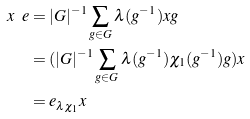<formula> <loc_0><loc_0><loc_500><loc_500>x \ e & = | G | ^ { - 1 } \sum _ { g \in G } \lambda ( g ^ { - 1 } ) x g \\ & = ( | G | ^ { - 1 } \sum _ { g \in G } \lambda ( g ^ { - 1 } ) \chi _ { 1 } ( g ^ { - 1 } ) g ) x \\ & = e _ { { \lambda } \chi _ { 1 } } x</formula> 